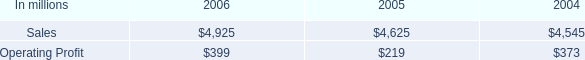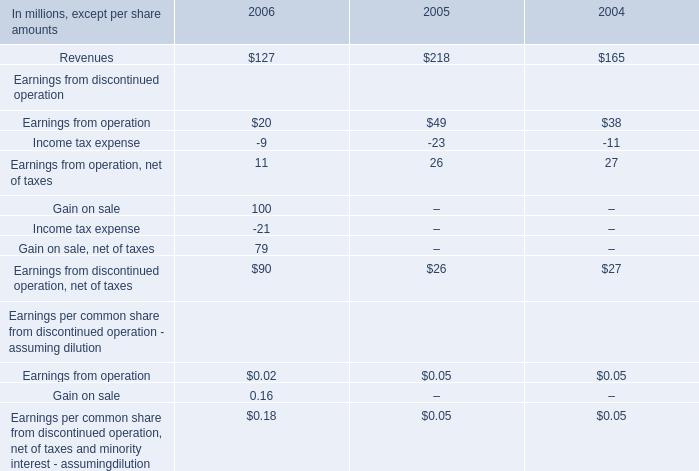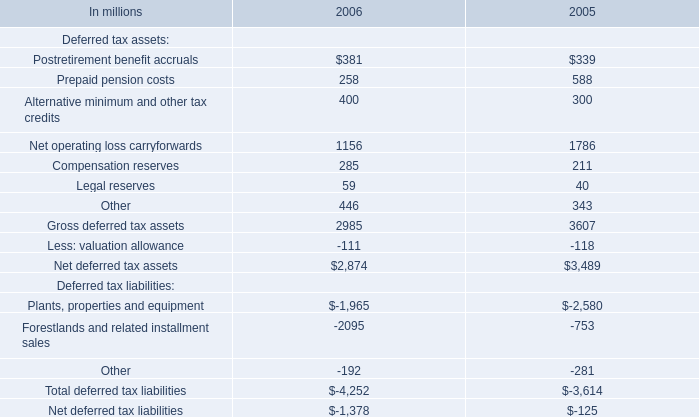what percentage of 2006 industrial packaging sales are containerboard sales? 
Computations: (955 / 4925)
Answer: 0.19391. 